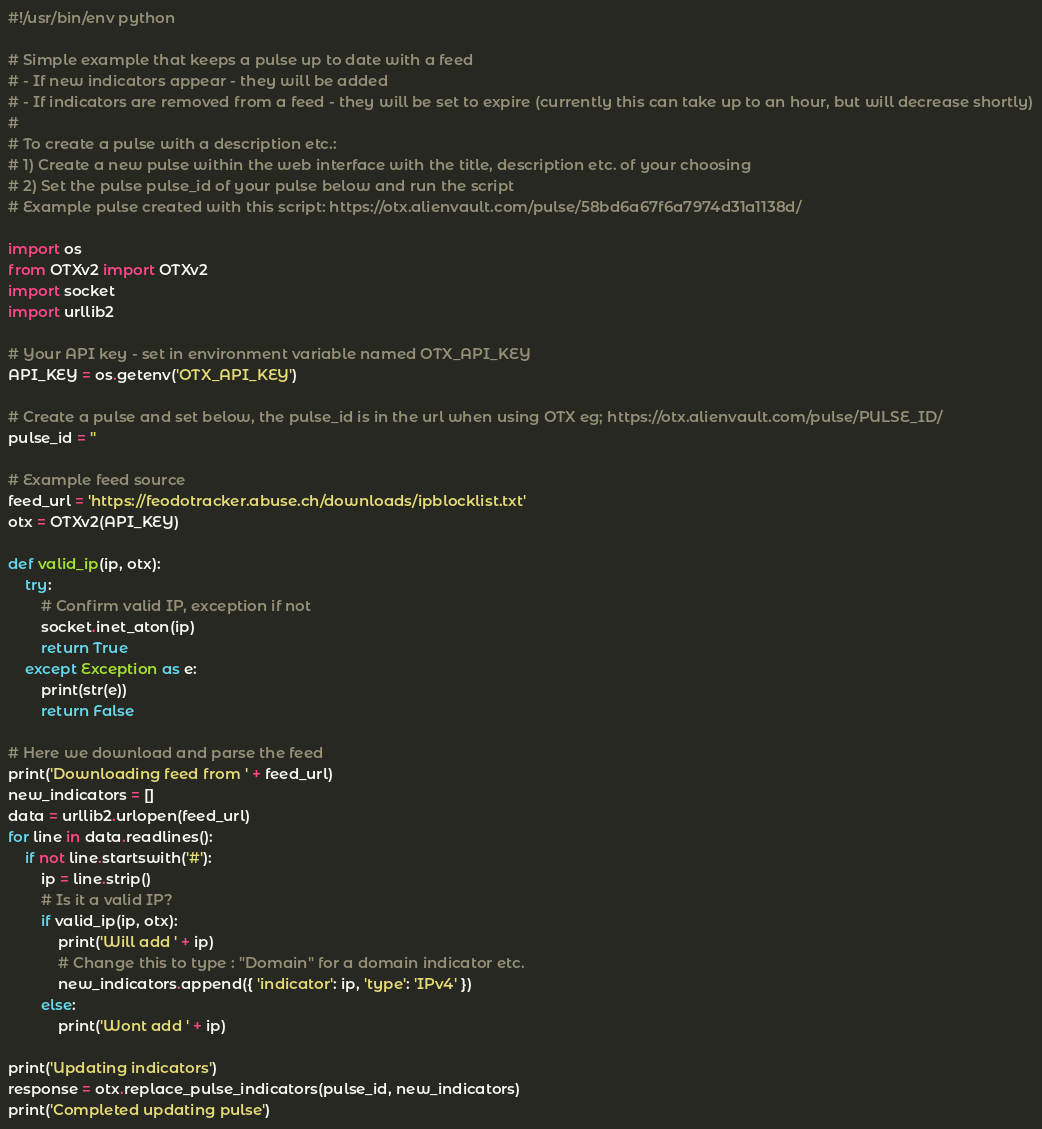<code> <loc_0><loc_0><loc_500><loc_500><_Python_>#!/usr/bin/env python

# Simple example that keeps a pulse up to date with a feed
# - If new indicators appear - they will be added
# - If indicators are removed from a feed - they will be set to expire (currently this can take up to an hour, but will decrease shortly)
#
# To create a pulse with a description etc.:
# 1) Create a new pulse within the web interface with the title, description etc. of your choosing
# 2) Set the pulse pulse_id of your pulse below and run the script
# Example pulse created with this script: https://otx.alienvault.com/pulse/58bd6a67f6a7974d31a1138d/

import os
from OTXv2 import OTXv2
import socket
import urllib2

# Your API key - set in environment variable named OTX_API_KEY
API_KEY = os.getenv('OTX_API_KEY')

# Create a pulse and set below, the pulse_id is in the url when using OTX eg; https://otx.alienvault.com/pulse/PULSE_ID/
pulse_id = ''

# Example feed source
feed_url = 'https://feodotracker.abuse.ch/downloads/ipblocklist.txt'
otx = OTXv2(API_KEY)

def valid_ip(ip, otx):
    try:
        # Confirm valid IP, exception if not
        socket.inet_aton(ip)
        return True
    except Exception as e:
        print(str(e))
        return False

# Here we download and parse the feed
print('Downloading feed from ' + feed_url)
new_indicators = []
data = urllib2.urlopen(feed_url)
for line in data.readlines():
    if not line.startswith('#'):
        ip = line.strip()
        # Is it a valid IP?
        if valid_ip(ip, otx):
            print('Will add ' + ip)
            # Change this to type : "Domain" for a domain indicator etc.
            new_indicators.append({ 'indicator': ip, 'type': 'IPv4' })
        else:
            print('Wont add ' + ip)

print('Updating indicators')
response = otx.replace_pulse_indicators(pulse_id, new_indicators)
print('Completed updating pulse')
</code> 